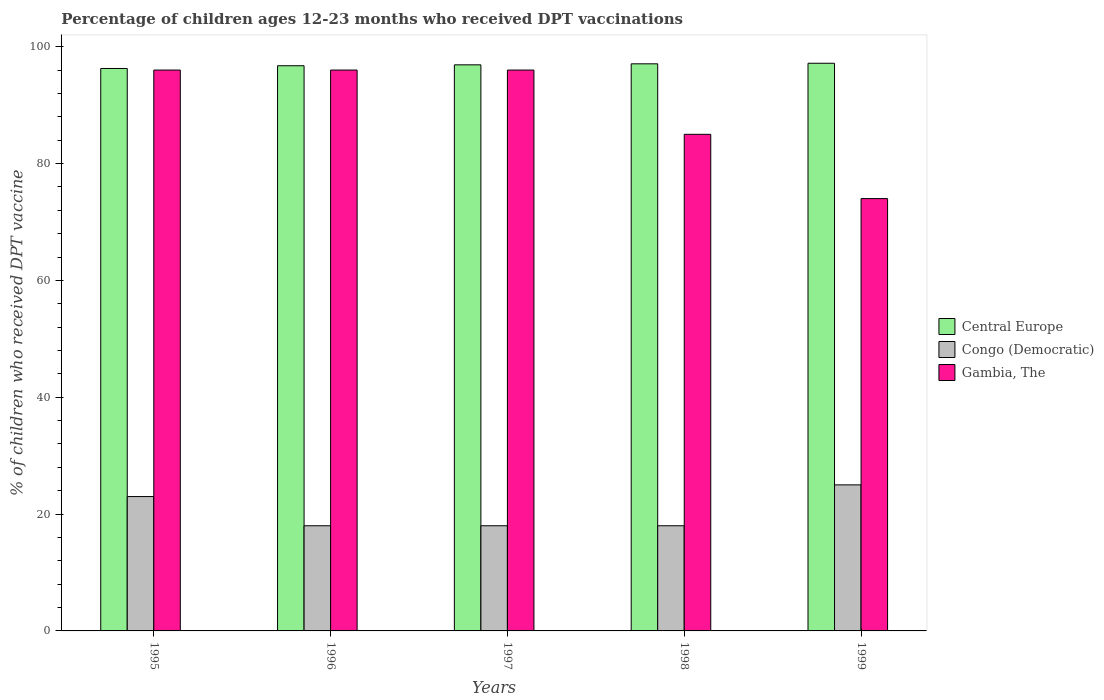How many different coloured bars are there?
Your response must be concise. 3. Are the number of bars on each tick of the X-axis equal?
Provide a succinct answer. Yes. How many bars are there on the 4th tick from the left?
Provide a short and direct response. 3. What is the label of the 3rd group of bars from the left?
Provide a succinct answer. 1997. In how many cases, is the number of bars for a given year not equal to the number of legend labels?
Offer a very short reply. 0. What is the percentage of children who received DPT vaccination in Central Europe in 1998?
Your answer should be very brief. 97.07. Across all years, what is the maximum percentage of children who received DPT vaccination in Gambia, The?
Offer a terse response. 96. Across all years, what is the minimum percentage of children who received DPT vaccination in Central Europe?
Give a very brief answer. 96.27. In which year was the percentage of children who received DPT vaccination in Congo (Democratic) maximum?
Ensure brevity in your answer.  1999. In which year was the percentage of children who received DPT vaccination in Gambia, The minimum?
Provide a short and direct response. 1999. What is the total percentage of children who received DPT vaccination in Central Europe in the graph?
Ensure brevity in your answer.  484.13. What is the difference between the percentage of children who received DPT vaccination in Gambia, The in 1997 and that in 1998?
Your answer should be very brief. 11. What is the difference between the percentage of children who received DPT vaccination in Congo (Democratic) in 1999 and the percentage of children who received DPT vaccination in Central Europe in 1995?
Offer a very short reply. -71.27. What is the average percentage of children who received DPT vaccination in Congo (Democratic) per year?
Offer a very short reply. 20.4. In the year 1996, what is the difference between the percentage of children who received DPT vaccination in Gambia, The and percentage of children who received DPT vaccination in Central Europe?
Provide a succinct answer. -0.74. What is the ratio of the percentage of children who received DPT vaccination in Gambia, The in 1995 to that in 1999?
Your answer should be very brief. 1.3. What is the difference between the highest and the second highest percentage of children who received DPT vaccination in Central Europe?
Your answer should be very brief. 0.1. What is the difference between the highest and the lowest percentage of children who received DPT vaccination in Central Europe?
Give a very brief answer. 0.89. Is the sum of the percentage of children who received DPT vaccination in Central Europe in 1997 and 1998 greater than the maximum percentage of children who received DPT vaccination in Gambia, The across all years?
Your answer should be very brief. Yes. What does the 3rd bar from the left in 1998 represents?
Your answer should be compact. Gambia, The. What does the 2nd bar from the right in 1996 represents?
Keep it short and to the point. Congo (Democratic). Is it the case that in every year, the sum of the percentage of children who received DPT vaccination in Gambia, The and percentage of children who received DPT vaccination in Central Europe is greater than the percentage of children who received DPT vaccination in Congo (Democratic)?
Provide a short and direct response. Yes. Where does the legend appear in the graph?
Make the answer very short. Center right. How are the legend labels stacked?
Your response must be concise. Vertical. What is the title of the graph?
Make the answer very short. Percentage of children ages 12-23 months who received DPT vaccinations. Does "Micronesia" appear as one of the legend labels in the graph?
Your response must be concise. No. What is the label or title of the X-axis?
Keep it short and to the point. Years. What is the label or title of the Y-axis?
Make the answer very short. % of children who received DPT vaccine. What is the % of children who received DPT vaccine in Central Europe in 1995?
Keep it short and to the point. 96.27. What is the % of children who received DPT vaccine of Congo (Democratic) in 1995?
Offer a terse response. 23. What is the % of children who received DPT vaccine in Gambia, The in 1995?
Your answer should be very brief. 96. What is the % of children who received DPT vaccine of Central Europe in 1996?
Your answer should be compact. 96.74. What is the % of children who received DPT vaccine of Congo (Democratic) in 1996?
Make the answer very short. 18. What is the % of children who received DPT vaccine in Gambia, The in 1996?
Provide a succinct answer. 96. What is the % of children who received DPT vaccine of Central Europe in 1997?
Your answer should be compact. 96.89. What is the % of children who received DPT vaccine of Congo (Democratic) in 1997?
Your response must be concise. 18. What is the % of children who received DPT vaccine in Gambia, The in 1997?
Give a very brief answer. 96. What is the % of children who received DPT vaccine in Central Europe in 1998?
Give a very brief answer. 97.07. What is the % of children who received DPT vaccine of Congo (Democratic) in 1998?
Give a very brief answer. 18. What is the % of children who received DPT vaccine in Gambia, The in 1998?
Your answer should be compact. 85. What is the % of children who received DPT vaccine in Central Europe in 1999?
Offer a terse response. 97.16. What is the % of children who received DPT vaccine in Gambia, The in 1999?
Keep it short and to the point. 74. Across all years, what is the maximum % of children who received DPT vaccine of Central Europe?
Your response must be concise. 97.16. Across all years, what is the maximum % of children who received DPT vaccine in Gambia, The?
Make the answer very short. 96. Across all years, what is the minimum % of children who received DPT vaccine in Central Europe?
Your answer should be compact. 96.27. Across all years, what is the minimum % of children who received DPT vaccine of Gambia, The?
Offer a very short reply. 74. What is the total % of children who received DPT vaccine in Central Europe in the graph?
Your answer should be very brief. 484.13. What is the total % of children who received DPT vaccine in Congo (Democratic) in the graph?
Provide a short and direct response. 102. What is the total % of children who received DPT vaccine in Gambia, The in the graph?
Offer a terse response. 447. What is the difference between the % of children who received DPT vaccine in Central Europe in 1995 and that in 1996?
Make the answer very short. -0.47. What is the difference between the % of children who received DPT vaccine in Congo (Democratic) in 1995 and that in 1996?
Offer a very short reply. 5. What is the difference between the % of children who received DPT vaccine of Central Europe in 1995 and that in 1997?
Keep it short and to the point. -0.62. What is the difference between the % of children who received DPT vaccine in Gambia, The in 1995 and that in 1997?
Provide a succinct answer. 0. What is the difference between the % of children who received DPT vaccine in Central Europe in 1995 and that in 1998?
Your answer should be very brief. -0.8. What is the difference between the % of children who received DPT vaccine in Central Europe in 1995 and that in 1999?
Offer a very short reply. -0.89. What is the difference between the % of children who received DPT vaccine in Congo (Democratic) in 1995 and that in 1999?
Make the answer very short. -2. What is the difference between the % of children who received DPT vaccine in Gambia, The in 1995 and that in 1999?
Ensure brevity in your answer.  22. What is the difference between the % of children who received DPT vaccine in Central Europe in 1996 and that in 1997?
Offer a very short reply. -0.15. What is the difference between the % of children who received DPT vaccine of Congo (Democratic) in 1996 and that in 1997?
Make the answer very short. 0. What is the difference between the % of children who received DPT vaccine in Central Europe in 1996 and that in 1998?
Keep it short and to the point. -0.33. What is the difference between the % of children who received DPT vaccine in Gambia, The in 1996 and that in 1998?
Your answer should be very brief. 11. What is the difference between the % of children who received DPT vaccine of Central Europe in 1996 and that in 1999?
Offer a terse response. -0.42. What is the difference between the % of children who received DPT vaccine in Gambia, The in 1996 and that in 1999?
Your answer should be compact. 22. What is the difference between the % of children who received DPT vaccine of Central Europe in 1997 and that in 1998?
Offer a terse response. -0.18. What is the difference between the % of children who received DPT vaccine in Gambia, The in 1997 and that in 1998?
Keep it short and to the point. 11. What is the difference between the % of children who received DPT vaccine of Central Europe in 1997 and that in 1999?
Offer a terse response. -0.27. What is the difference between the % of children who received DPT vaccine in Gambia, The in 1997 and that in 1999?
Offer a very short reply. 22. What is the difference between the % of children who received DPT vaccine in Central Europe in 1998 and that in 1999?
Provide a short and direct response. -0.1. What is the difference between the % of children who received DPT vaccine of Gambia, The in 1998 and that in 1999?
Your answer should be very brief. 11. What is the difference between the % of children who received DPT vaccine in Central Europe in 1995 and the % of children who received DPT vaccine in Congo (Democratic) in 1996?
Offer a very short reply. 78.27. What is the difference between the % of children who received DPT vaccine of Central Europe in 1995 and the % of children who received DPT vaccine of Gambia, The in 1996?
Your answer should be compact. 0.27. What is the difference between the % of children who received DPT vaccine in Congo (Democratic) in 1995 and the % of children who received DPT vaccine in Gambia, The in 1996?
Provide a succinct answer. -73. What is the difference between the % of children who received DPT vaccine in Central Europe in 1995 and the % of children who received DPT vaccine in Congo (Democratic) in 1997?
Make the answer very short. 78.27. What is the difference between the % of children who received DPT vaccine of Central Europe in 1995 and the % of children who received DPT vaccine of Gambia, The in 1997?
Offer a very short reply. 0.27. What is the difference between the % of children who received DPT vaccine of Congo (Democratic) in 1995 and the % of children who received DPT vaccine of Gambia, The in 1997?
Offer a terse response. -73. What is the difference between the % of children who received DPT vaccine of Central Europe in 1995 and the % of children who received DPT vaccine of Congo (Democratic) in 1998?
Make the answer very short. 78.27. What is the difference between the % of children who received DPT vaccine of Central Europe in 1995 and the % of children who received DPT vaccine of Gambia, The in 1998?
Your answer should be very brief. 11.27. What is the difference between the % of children who received DPT vaccine of Congo (Democratic) in 1995 and the % of children who received DPT vaccine of Gambia, The in 1998?
Offer a terse response. -62. What is the difference between the % of children who received DPT vaccine of Central Europe in 1995 and the % of children who received DPT vaccine of Congo (Democratic) in 1999?
Offer a terse response. 71.27. What is the difference between the % of children who received DPT vaccine in Central Europe in 1995 and the % of children who received DPT vaccine in Gambia, The in 1999?
Offer a terse response. 22.27. What is the difference between the % of children who received DPT vaccine in Congo (Democratic) in 1995 and the % of children who received DPT vaccine in Gambia, The in 1999?
Your response must be concise. -51. What is the difference between the % of children who received DPT vaccine of Central Europe in 1996 and the % of children who received DPT vaccine of Congo (Democratic) in 1997?
Keep it short and to the point. 78.74. What is the difference between the % of children who received DPT vaccine of Central Europe in 1996 and the % of children who received DPT vaccine of Gambia, The in 1997?
Ensure brevity in your answer.  0.74. What is the difference between the % of children who received DPT vaccine in Congo (Democratic) in 1996 and the % of children who received DPT vaccine in Gambia, The in 1997?
Provide a succinct answer. -78. What is the difference between the % of children who received DPT vaccine of Central Europe in 1996 and the % of children who received DPT vaccine of Congo (Democratic) in 1998?
Ensure brevity in your answer.  78.74. What is the difference between the % of children who received DPT vaccine in Central Europe in 1996 and the % of children who received DPT vaccine in Gambia, The in 1998?
Your answer should be compact. 11.74. What is the difference between the % of children who received DPT vaccine in Congo (Democratic) in 1996 and the % of children who received DPT vaccine in Gambia, The in 1998?
Give a very brief answer. -67. What is the difference between the % of children who received DPT vaccine of Central Europe in 1996 and the % of children who received DPT vaccine of Congo (Democratic) in 1999?
Offer a terse response. 71.74. What is the difference between the % of children who received DPT vaccine of Central Europe in 1996 and the % of children who received DPT vaccine of Gambia, The in 1999?
Give a very brief answer. 22.74. What is the difference between the % of children who received DPT vaccine in Congo (Democratic) in 1996 and the % of children who received DPT vaccine in Gambia, The in 1999?
Offer a very short reply. -56. What is the difference between the % of children who received DPT vaccine in Central Europe in 1997 and the % of children who received DPT vaccine in Congo (Democratic) in 1998?
Ensure brevity in your answer.  78.89. What is the difference between the % of children who received DPT vaccine of Central Europe in 1997 and the % of children who received DPT vaccine of Gambia, The in 1998?
Your answer should be compact. 11.89. What is the difference between the % of children who received DPT vaccine in Congo (Democratic) in 1997 and the % of children who received DPT vaccine in Gambia, The in 1998?
Offer a terse response. -67. What is the difference between the % of children who received DPT vaccine of Central Europe in 1997 and the % of children who received DPT vaccine of Congo (Democratic) in 1999?
Provide a succinct answer. 71.89. What is the difference between the % of children who received DPT vaccine in Central Europe in 1997 and the % of children who received DPT vaccine in Gambia, The in 1999?
Provide a short and direct response. 22.89. What is the difference between the % of children who received DPT vaccine of Congo (Democratic) in 1997 and the % of children who received DPT vaccine of Gambia, The in 1999?
Provide a short and direct response. -56. What is the difference between the % of children who received DPT vaccine of Central Europe in 1998 and the % of children who received DPT vaccine of Congo (Democratic) in 1999?
Keep it short and to the point. 72.07. What is the difference between the % of children who received DPT vaccine of Central Europe in 1998 and the % of children who received DPT vaccine of Gambia, The in 1999?
Your answer should be very brief. 23.07. What is the difference between the % of children who received DPT vaccine of Congo (Democratic) in 1998 and the % of children who received DPT vaccine of Gambia, The in 1999?
Your answer should be very brief. -56. What is the average % of children who received DPT vaccine in Central Europe per year?
Your answer should be compact. 96.83. What is the average % of children who received DPT vaccine in Congo (Democratic) per year?
Offer a terse response. 20.4. What is the average % of children who received DPT vaccine of Gambia, The per year?
Your response must be concise. 89.4. In the year 1995, what is the difference between the % of children who received DPT vaccine of Central Europe and % of children who received DPT vaccine of Congo (Democratic)?
Provide a short and direct response. 73.27. In the year 1995, what is the difference between the % of children who received DPT vaccine in Central Europe and % of children who received DPT vaccine in Gambia, The?
Keep it short and to the point. 0.27. In the year 1995, what is the difference between the % of children who received DPT vaccine in Congo (Democratic) and % of children who received DPT vaccine in Gambia, The?
Offer a very short reply. -73. In the year 1996, what is the difference between the % of children who received DPT vaccine of Central Europe and % of children who received DPT vaccine of Congo (Democratic)?
Keep it short and to the point. 78.74. In the year 1996, what is the difference between the % of children who received DPT vaccine of Central Europe and % of children who received DPT vaccine of Gambia, The?
Provide a succinct answer. 0.74. In the year 1996, what is the difference between the % of children who received DPT vaccine in Congo (Democratic) and % of children who received DPT vaccine in Gambia, The?
Provide a short and direct response. -78. In the year 1997, what is the difference between the % of children who received DPT vaccine of Central Europe and % of children who received DPT vaccine of Congo (Democratic)?
Make the answer very short. 78.89. In the year 1997, what is the difference between the % of children who received DPT vaccine of Central Europe and % of children who received DPT vaccine of Gambia, The?
Make the answer very short. 0.89. In the year 1997, what is the difference between the % of children who received DPT vaccine of Congo (Democratic) and % of children who received DPT vaccine of Gambia, The?
Your answer should be very brief. -78. In the year 1998, what is the difference between the % of children who received DPT vaccine in Central Europe and % of children who received DPT vaccine in Congo (Democratic)?
Give a very brief answer. 79.07. In the year 1998, what is the difference between the % of children who received DPT vaccine of Central Europe and % of children who received DPT vaccine of Gambia, The?
Ensure brevity in your answer.  12.07. In the year 1998, what is the difference between the % of children who received DPT vaccine in Congo (Democratic) and % of children who received DPT vaccine in Gambia, The?
Provide a short and direct response. -67. In the year 1999, what is the difference between the % of children who received DPT vaccine of Central Europe and % of children who received DPT vaccine of Congo (Democratic)?
Give a very brief answer. 72.16. In the year 1999, what is the difference between the % of children who received DPT vaccine of Central Europe and % of children who received DPT vaccine of Gambia, The?
Provide a short and direct response. 23.16. In the year 1999, what is the difference between the % of children who received DPT vaccine in Congo (Democratic) and % of children who received DPT vaccine in Gambia, The?
Ensure brevity in your answer.  -49. What is the ratio of the % of children who received DPT vaccine in Congo (Democratic) in 1995 to that in 1996?
Provide a succinct answer. 1.28. What is the ratio of the % of children who received DPT vaccine of Central Europe in 1995 to that in 1997?
Offer a very short reply. 0.99. What is the ratio of the % of children who received DPT vaccine in Congo (Democratic) in 1995 to that in 1997?
Provide a short and direct response. 1.28. What is the ratio of the % of children who received DPT vaccine of Congo (Democratic) in 1995 to that in 1998?
Make the answer very short. 1.28. What is the ratio of the % of children who received DPT vaccine in Gambia, The in 1995 to that in 1998?
Your response must be concise. 1.13. What is the ratio of the % of children who received DPT vaccine of Congo (Democratic) in 1995 to that in 1999?
Your answer should be compact. 0.92. What is the ratio of the % of children who received DPT vaccine in Gambia, The in 1995 to that in 1999?
Offer a terse response. 1.3. What is the ratio of the % of children who received DPT vaccine in Central Europe in 1996 to that in 1997?
Your answer should be very brief. 1. What is the ratio of the % of children who received DPT vaccine in Congo (Democratic) in 1996 to that in 1997?
Provide a succinct answer. 1. What is the ratio of the % of children who received DPT vaccine of Congo (Democratic) in 1996 to that in 1998?
Provide a short and direct response. 1. What is the ratio of the % of children who received DPT vaccine of Gambia, The in 1996 to that in 1998?
Ensure brevity in your answer.  1.13. What is the ratio of the % of children who received DPT vaccine of Congo (Democratic) in 1996 to that in 1999?
Your response must be concise. 0.72. What is the ratio of the % of children who received DPT vaccine in Gambia, The in 1996 to that in 1999?
Ensure brevity in your answer.  1.3. What is the ratio of the % of children who received DPT vaccine of Central Europe in 1997 to that in 1998?
Your answer should be compact. 1. What is the ratio of the % of children who received DPT vaccine in Gambia, The in 1997 to that in 1998?
Your response must be concise. 1.13. What is the ratio of the % of children who received DPT vaccine of Congo (Democratic) in 1997 to that in 1999?
Keep it short and to the point. 0.72. What is the ratio of the % of children who received DPT vaccine of Gambia, The in 1997 to that in 1999?
Ensure brevity in your answer.  1.3. What is the ratio of the % of children who received DPT vaccine in Central Europe in 1998 to that in 1999?
Provide a short and direct response. 1. What is the ratio of the % of children who received DPT vaccine of Congo (Democratic) in 1998 to that in 1999?
Your response must be concise. 0.72. What is the ratio of the % of children who received DPT vaccine of Gambia, The in 1998 to that in 1999?
Make the answer very short. 1.15. What is the difference between the highest and the second highest % of children who received DPT vaccine in Central Europe?
Make the answer very short. 0.1. What is the difference between the highest and the lowest % of children who received DPT vaccine of Central Europe?
Keep it short and to the point. 0.89. What is the difference between the highest and the lowest % of children who received DPT vaccine of Congo (Democratic)?
Provide a short and direct response. 7. What is the difference between the highest and the lowest % of children who received DPT vaccine of Gambia, The?
Ensure brevity in your answer.  22. 